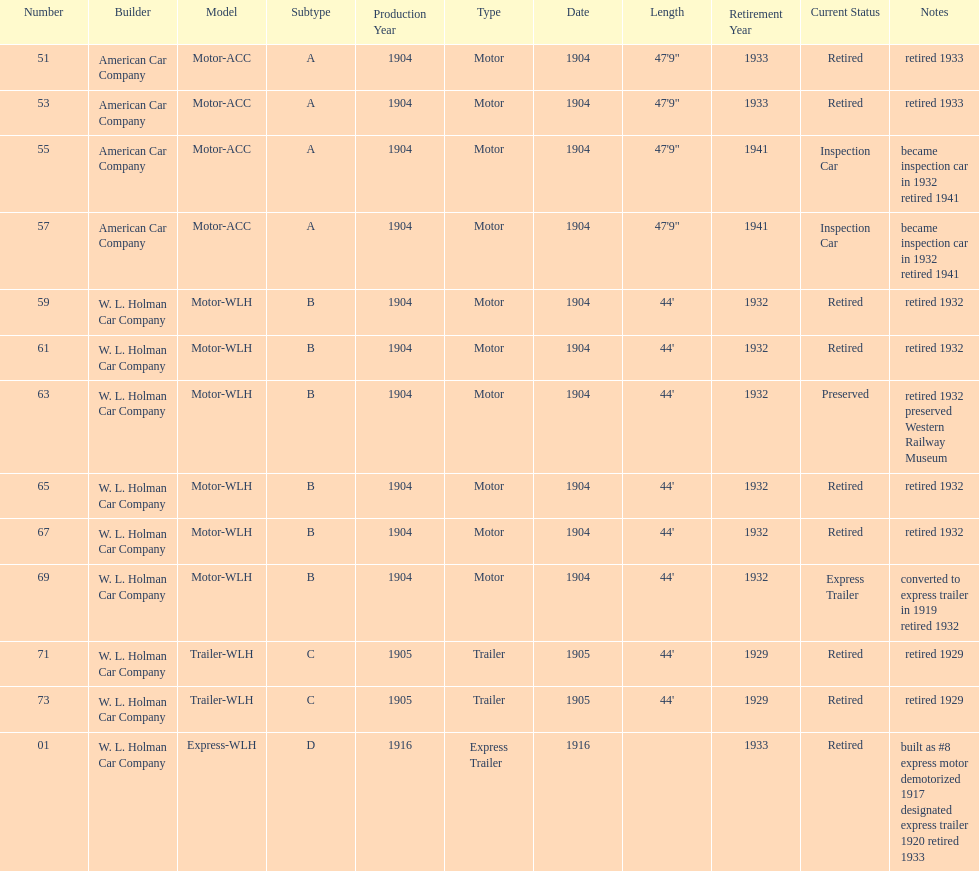What was the total number of cars listed? 13. 